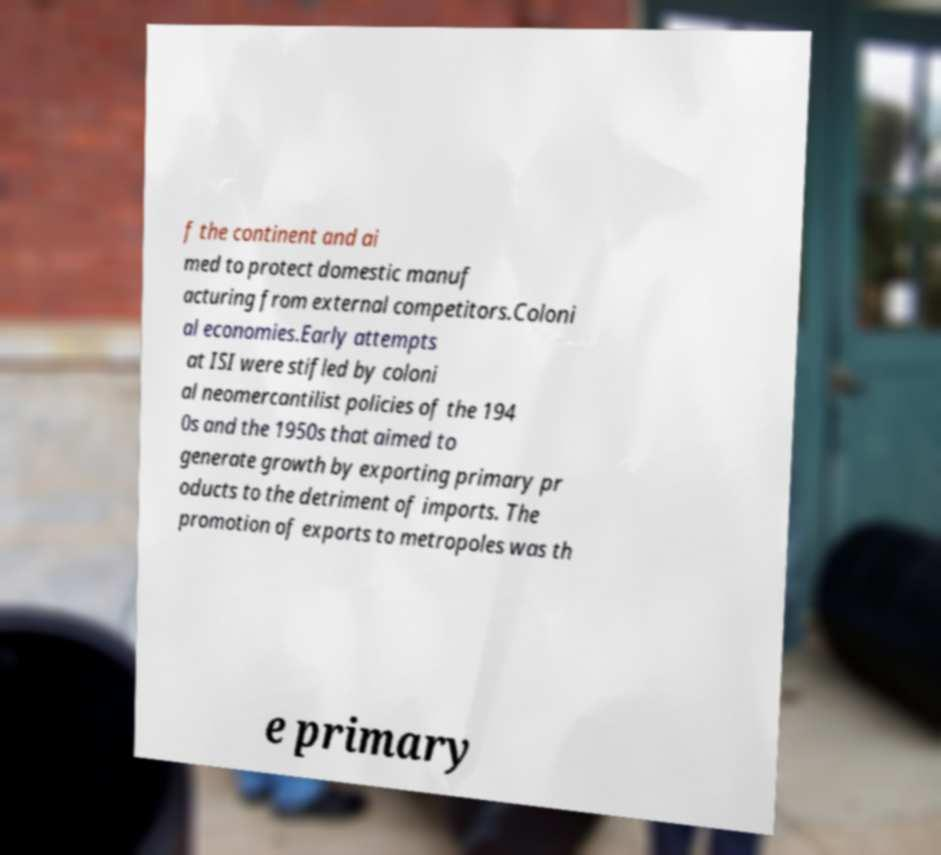Could you extract and type out the text from this image? f the continent and ai med to protect domestic manuf acturing from external competitors.Coloni al economies.Early attempts at ISI were stifled by coloni al neomercantilist policies of the 194 0s and the 1950s that aimed to generate growth by exporting primary pr oducts to the detriment of imports. The promotion of exports to metropoles was th e primary 